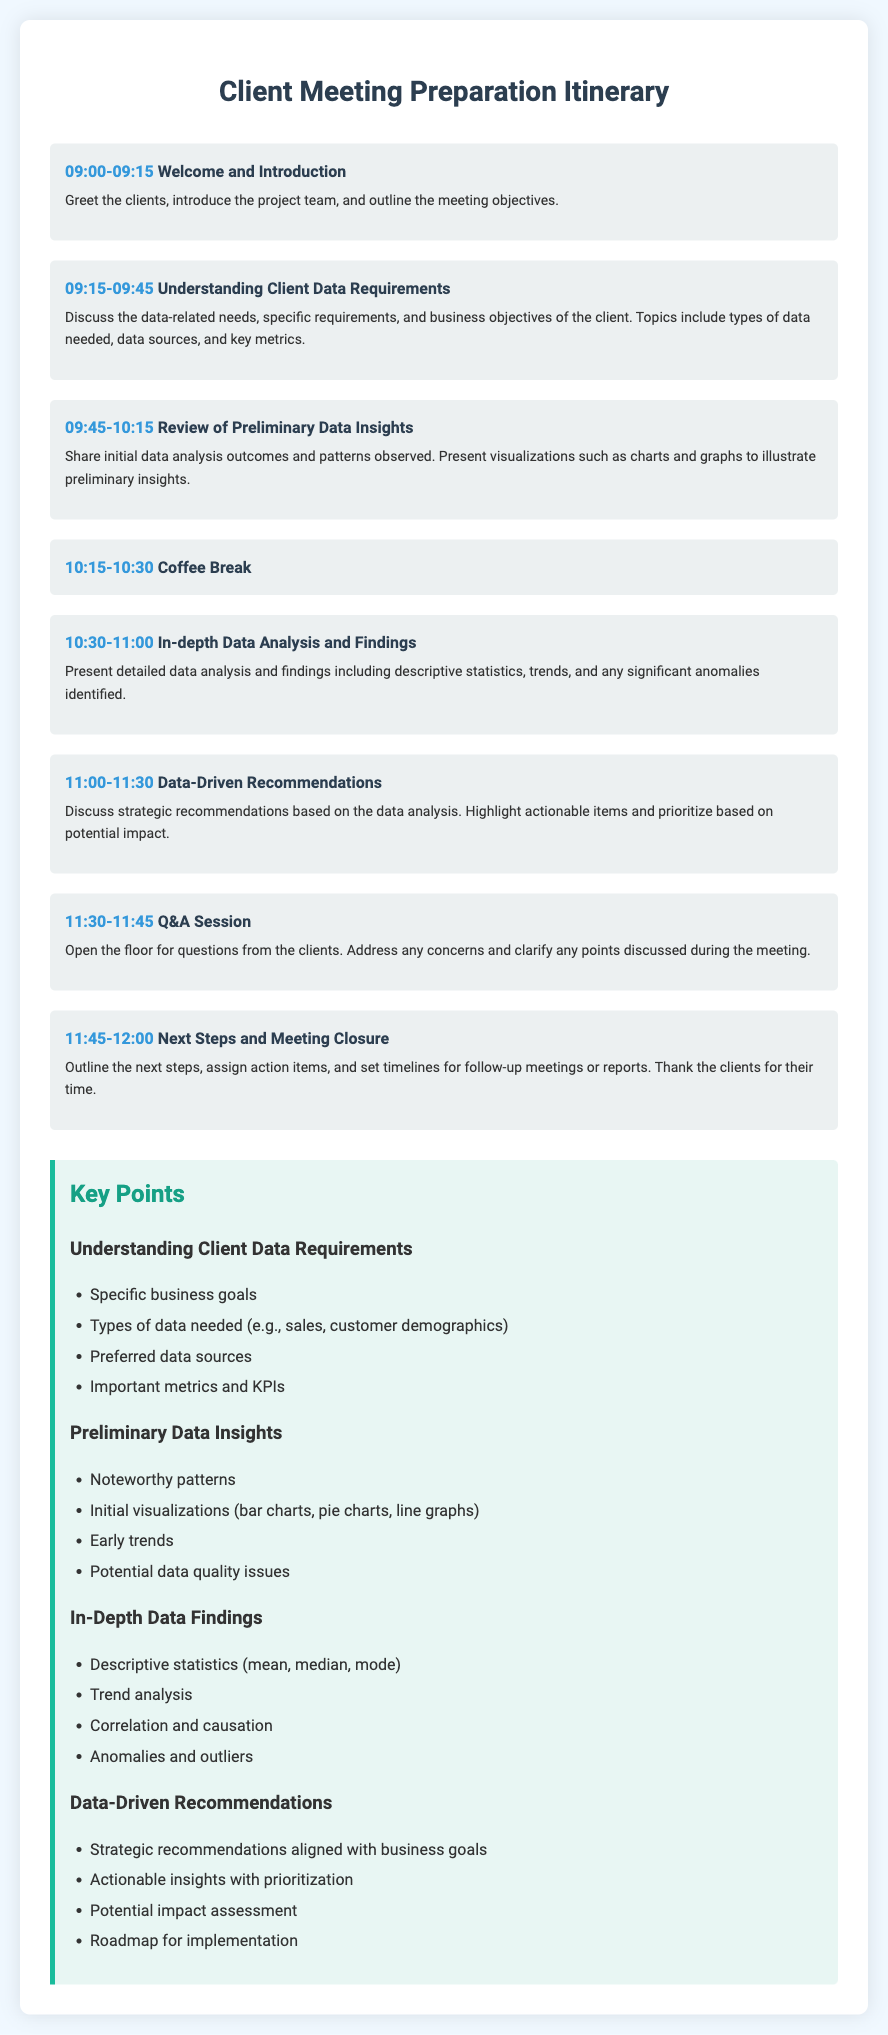What time does the meeting start? The meeting begins at 9:00 AM as indicated in the itinerary.
Answer: 09:00 What is discussed during the 10:30-11:00 time slot? This time slot is dedicated to the presentation of in-depth data analysis and findings.
Answer: In-depth Data Analysis and Findings How long is the coffee break in the agenda? The coffee break is specifically listed as lasting 15 minutes.
Answer: 15 minutes What are the key topics covered in the data-driven recommendations section? The key topics include strategic recommendations, actionable insights, potential impact assessment, and roadmap for implementation.
Answer: Strategic recommendations aligned with business goals During which part of the meeting are preliminary data insights shared? The preliminary data insights are shared in the agenda during the 9:45-10:15 time slot.
Answer: Review of Preliminary Data Insights What is one of the objectives outlined in the Welcome and Introduction? One of the objectives is to greet the clients and introduce the project team.
Answer: Outline the meeting objectives What is the total duration of the Q&A session? The Q&A session is scheduled to last for 15 minutes.
Answer: 15 minutes What types of data requirements are discussed with the client? The types of data required include sales and customer demographics, as specified in the key points section.
Answer: Types of data needed What is highlighted during the coffee break? No specific information is provided about activities during the coffee break, as it is a general break.
Answer: Coffee Break 